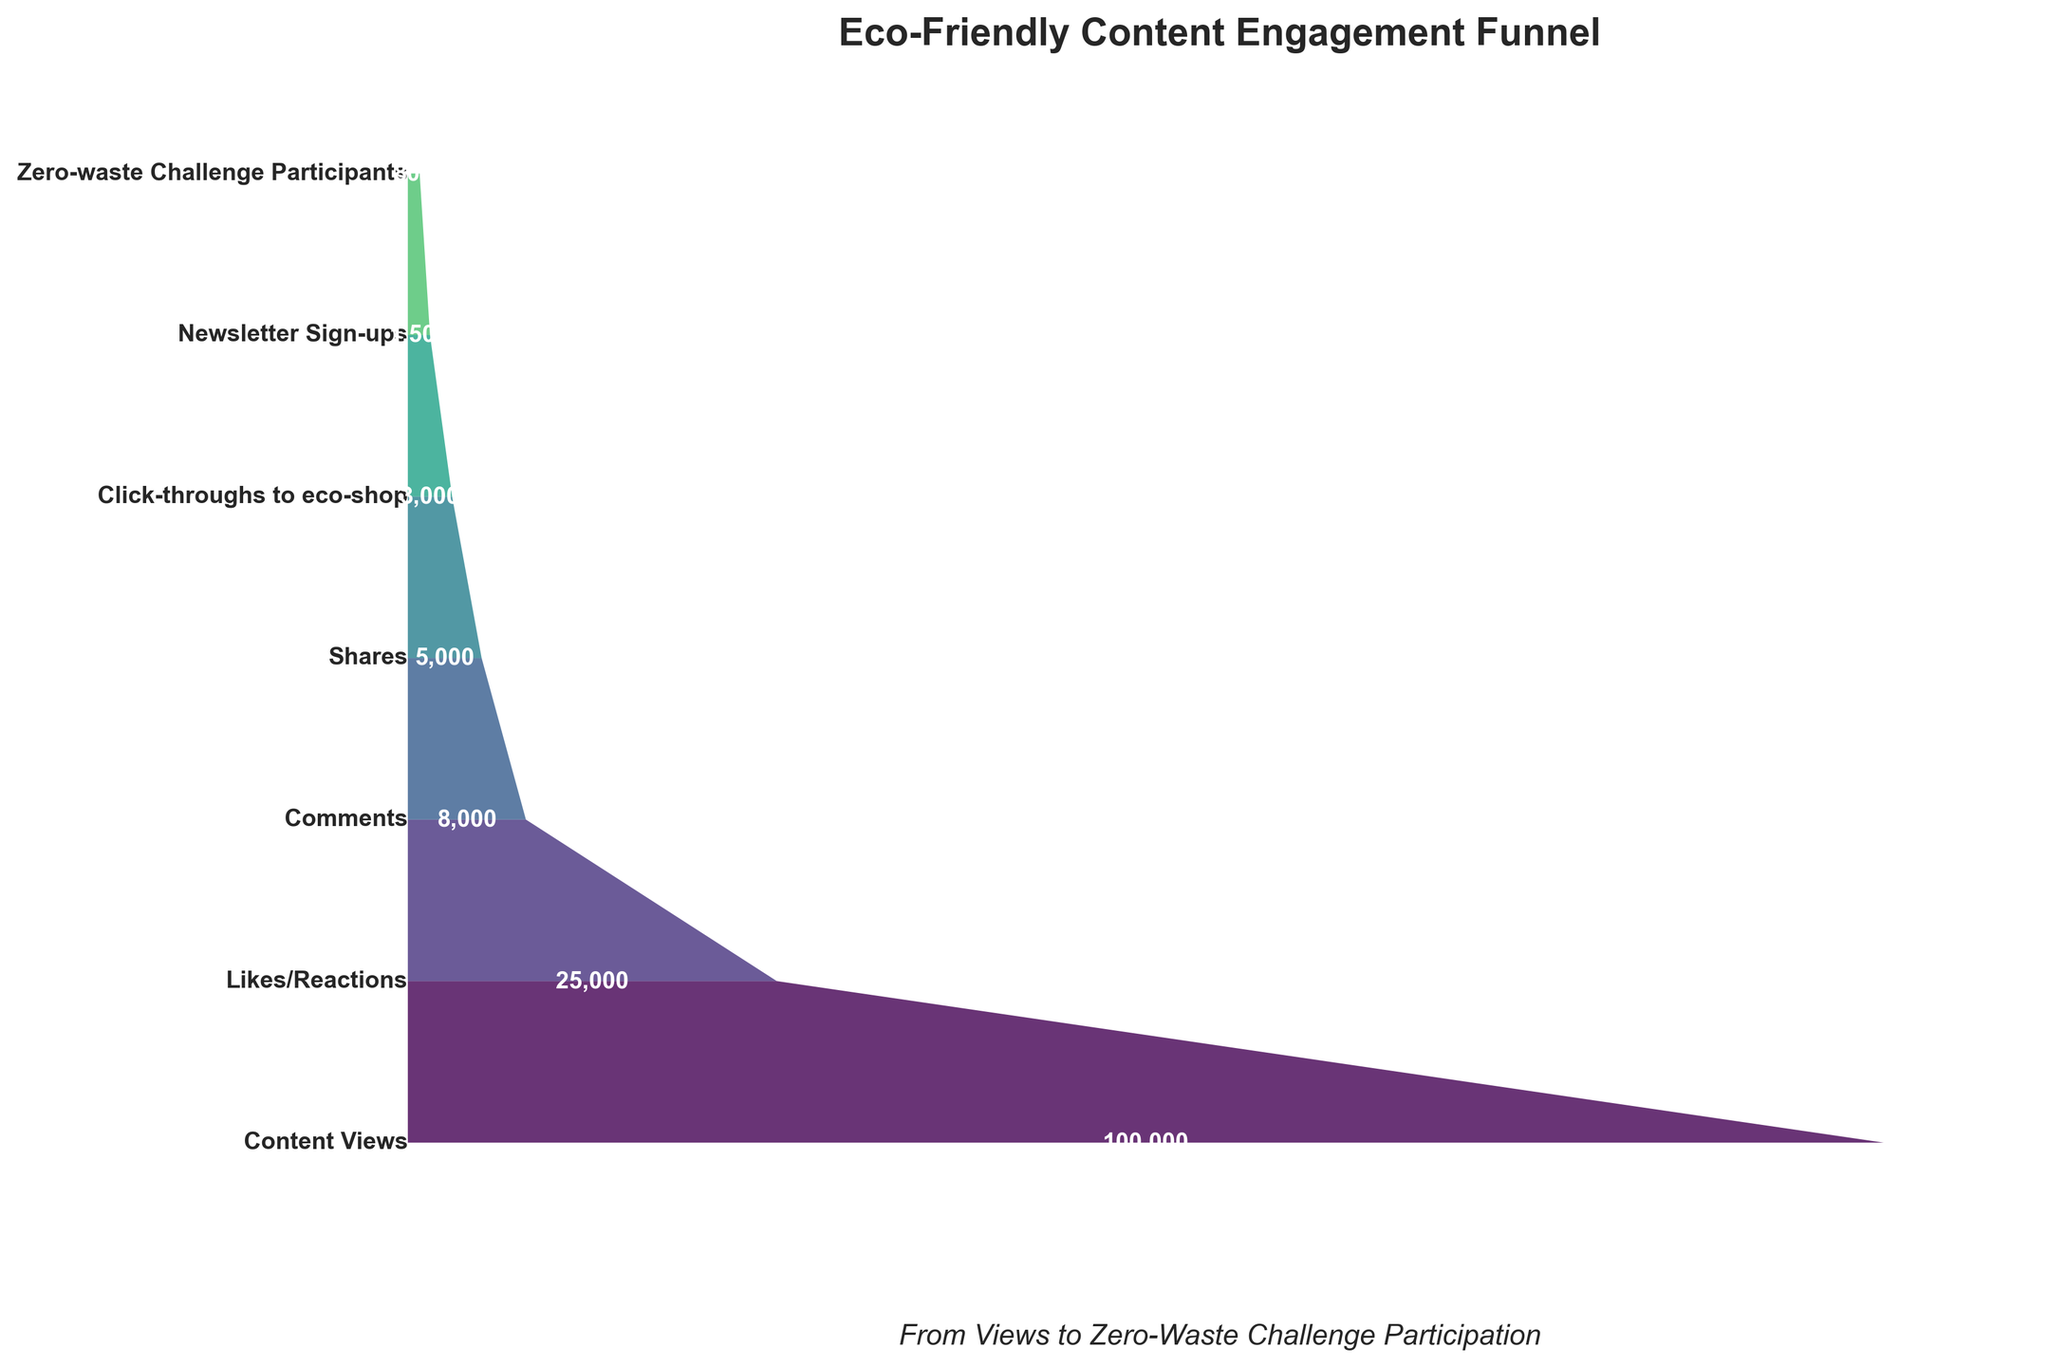What's the title of the funnel chart? The title is shown at the top of the figure. By looking there, you can see the exact labeling.
Answer: Eco-Friendly Content Engagement Funnel What stage has the highest number of users? To find this, look at the width at each level of the funnel. The widest segment corresponds to the stage with the highest users.
Answer: Content Views How many users participated in the Zero-Waste Challenge? This information is shown at the narrowest end of the funnel, labeled near the bottom.
Answer: 800 What can you infer about user engagement from Content Views to Newsletter Sign-ups? Start by noting the number of users at the Content Views stage and then at the Newsletter Sign-ups stage. You can see a significant decrease.
Answer: User engagement decreases sharply How many more users clicked through to the eco-shop compared to those who signed up for the newsletter? Calculate the difference between the users who clicked through to the eco-shop and those who signed up for the newsletter. Click-throughs to eco-shop: 3000, Newsletter Sign-ups: 1500. 3000 - 1500
Answer: 1500 By what percentage did users decrease from Likes/Reactions to Shares? Calculate the percentage decrease: (Likes/Reactions - Shares) / Likes/Reactions * 100. 25000 - 5000 = 20000. 20000 / 25000 * 100
Answer: 80% Which stage shows the steepest drop in user numbers? Examine the differences between consecutive stages. The steepest drop is where the difference is the largest.
Answer: Comments to Shares What is the ratio of Comments to Shares? Divide the number of Comments by the number of Shares. 8000 / 5000
Answer: 1.6 Comparing Click-throughs to eco-shop and Zero-waste Challenge Participants, which stage engaged more users? Look at the widths of the stages for both categories; click-throughs have a wider segment than Zero-waste Challenge Participants.
Answer: Click-throughs to eco-shop What can be observed about user behavior towards active participation stages like Zero-waste Challenge? Comparing the final stages in the funnel, the number of users declines significantly, indicating fewer users transition to highly active levels of engagement.
Answer: Participation significantly decreases 